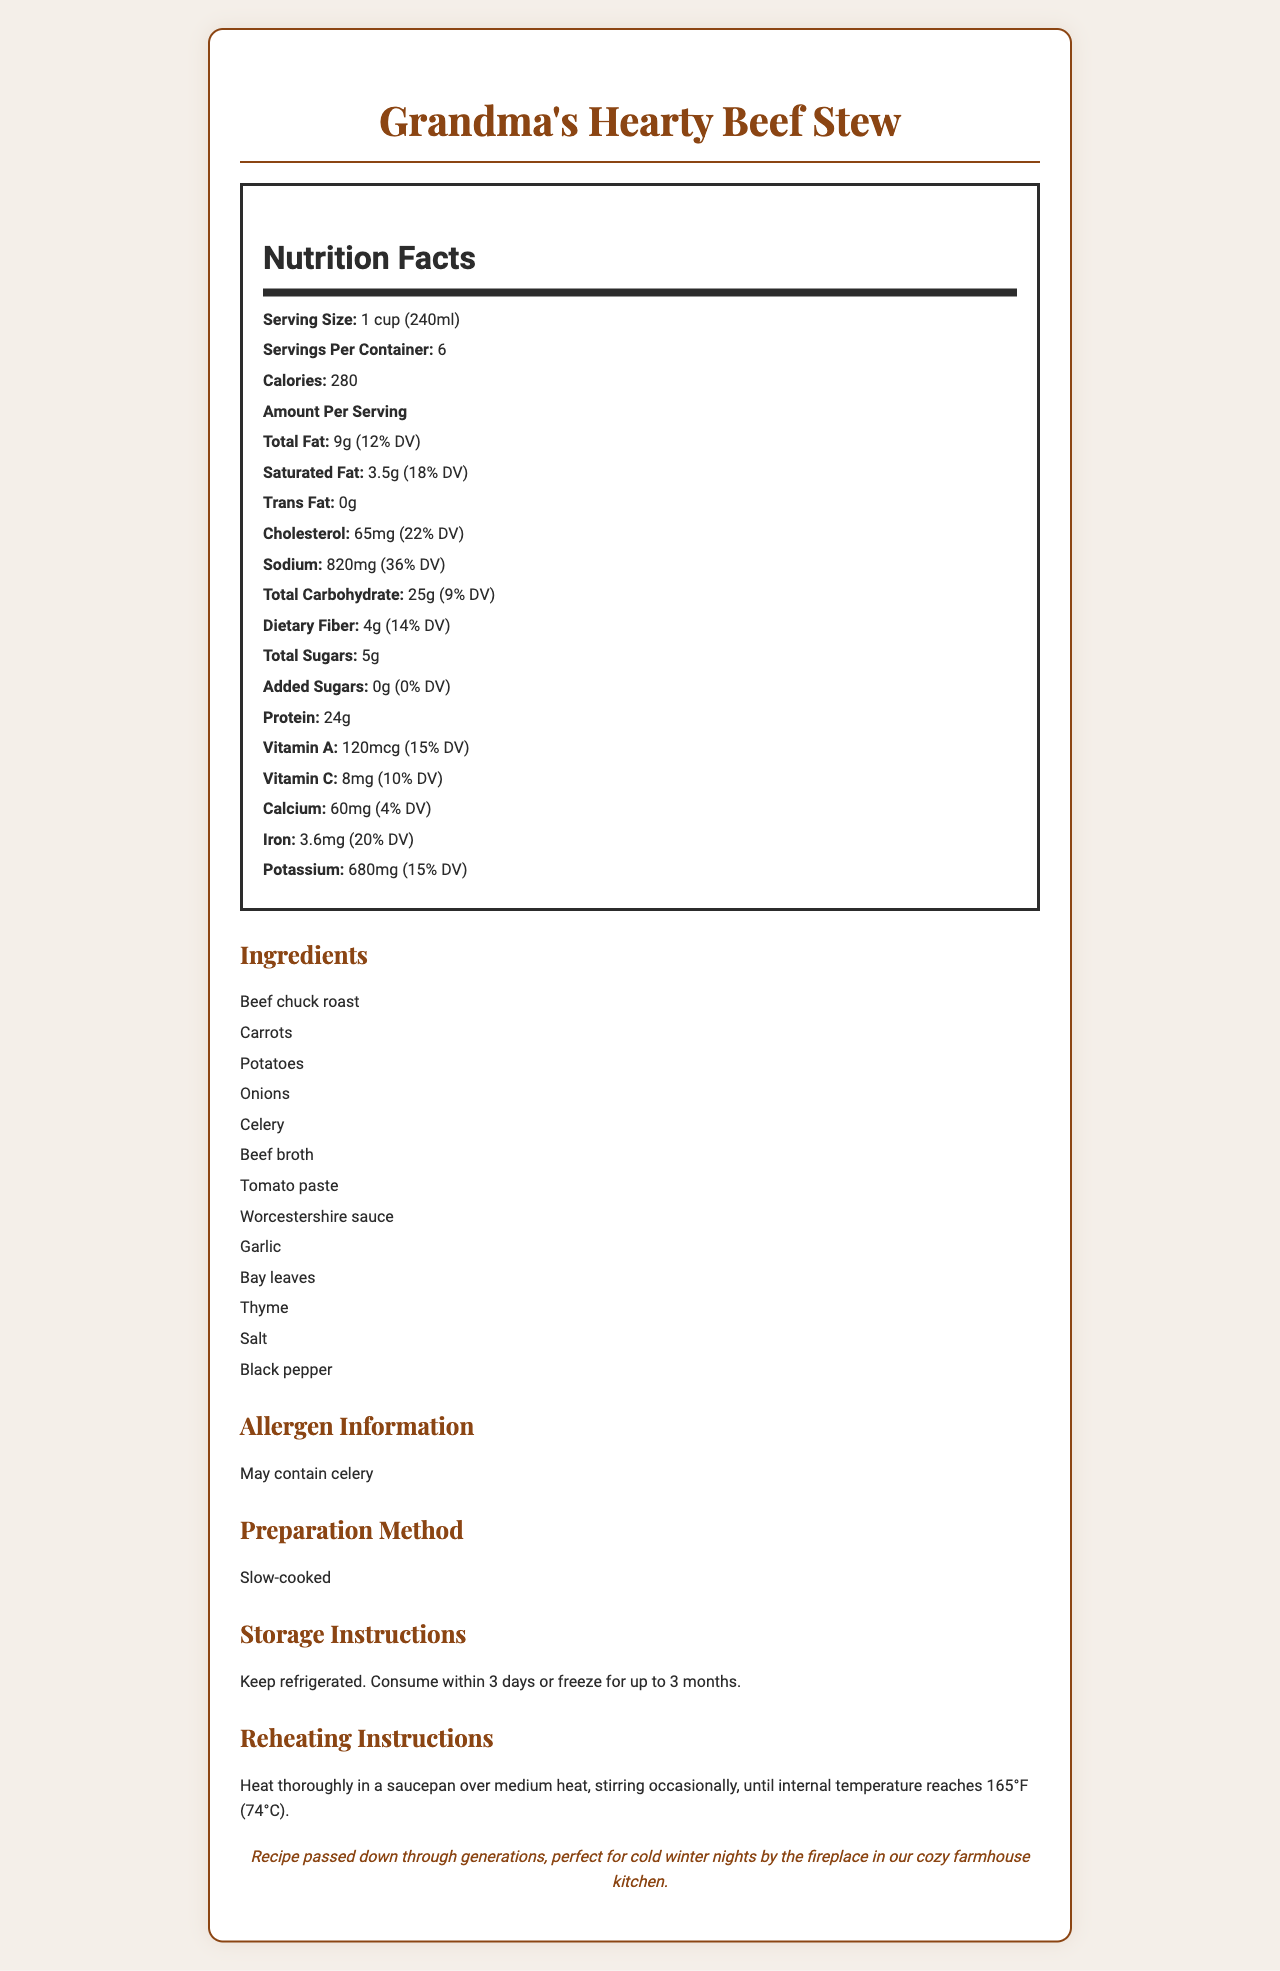what is the serving size? The serving size is specified as "1 cup (240ml)" at the beginning of the nutrition label.
Answer: 1 cup (240ml) how many calories are in one serving? The nutrition label lists the calories per serving as 280.
Answer: 280 what is the total fat content per serving? The label shows that the total fat content is 9 grams per serving.
Answer: 9g which ingredient is not definitely present but may be included? The allergen information mentions that the product may contain celery.
Answer: Celery how many grams of dietary fiber are there per serving? The dietary fiber content per serving is listed as 4 grams.
Answer: 4g how many servings are there per container? The document states there are 6 servings per container.
Answer: 6 how much sodium is there per serving? The sodium content per serving is listed as 820 milligrams.
Answer: 820mg how much vitamin A does each serving provide? A. 120mg B. 8mg C. 60mg D. 120mcg Each serving provides 120 micrograms (mcg) of vitamin A.
Answer: D. 120mcg how is the beef stew prepared? A. Oven-baked B. Slow-cooked C. Microwaved D. Boiled The preparation method is indicated as "Slow-cooked" in the document.
Answer: B. Slow-cooked does the stew contain added sugars? The label specifies that there are 0g of added sugars per serving.
Answer: No what are the reheating instructions? The reheating instructions clearly specify the required process.
Answer: Heat thoroughly in a saucepan over medium heat, stirring occasionally, until internal temperature reaches 165°F (74°C). what is the main idea of the document? The document is focused on giving a comprehensive overview of the beef stew, including nutrition facts, ingredient list, and various instructions for preparation and storage.
Answer: The document provides detailed nutritional information, ingredients, allergen warnings, preparation, storage, and reheating instructions for Grandma’s Hearty Beef Stew. does the stew contain any trans fat? The document indicates 0 grams of trans fat per serving.
Answer: No is the storage recommendation for freezing the stew longer than refrigeration? The document advises keeping it refrigerated for up to 3 days or freezing for up to 3 months.
Answer: Yes how many grams of saturated fat are there per serving? The label indicates there are 3.5 grams of saturated fat per serving.
Answer: 3.5g how much vitamin C is there per serving? Each serving has 8 milligrams of vitamin C according to the label.
Answer: 8mg how many grams of protein are in one serving of the stew? The protein content per serving is listed as 24 grams.
Answer: 24g which ingredient is responsible for the primary flavor enhancement? Worcestershire sauce is commonly used for flavor enhancement.
Answer: Worcestershire sauce can the document help in calculating total daily nutrient goals? The document provides daily value percentages but not detailed enough data for calculating total daily nutrient goals.
Answer: No 